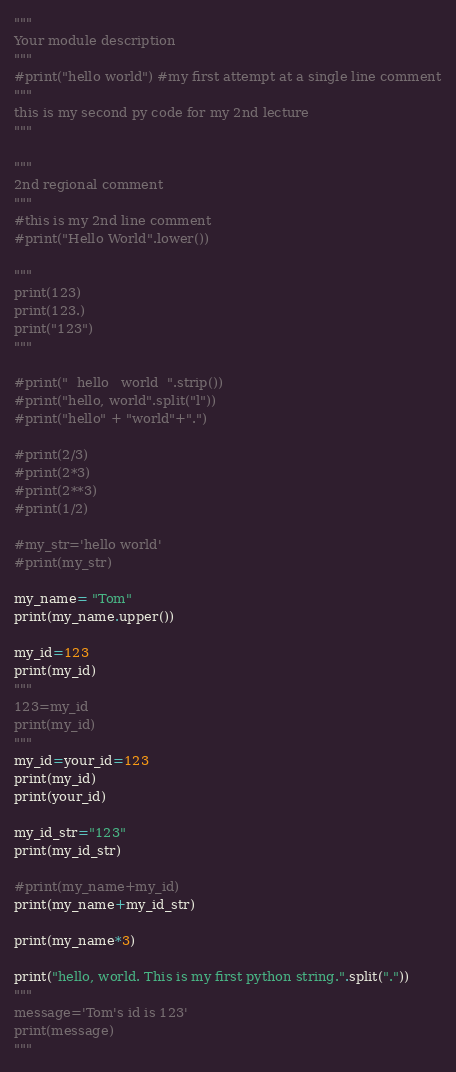Convert code to text. <code><loc_0><loc_0><loc_500><loc_500><_Python_>"""
Your module description
"""
#print("hello world") #my first attempt at a single line comment
"""
this is my second py code for my 2nd lecture
"""

"""
2nd regional comment
"""
#this is my 2nd line comment
#print("Hello World".lower())

"""
print(123)
print(123.)
print("123")
"""

#print("  hello   world  ".strip())
#print("hello, world".split("l"))
#print("hello" + "world"+".")

#print(2/3)
#print(2*3)
#print(2**3)
#print(1/2)

#my_str='hello world'
#print(my_str)

my_name= "Tom"
print(my_name.upper())

my_id=123
print(my_id)
"""
123=my_id
print(my_id)
"""
my_id=your_id=123
print(my_id)
print(your_id)

my_id_str="123"
print(my_id_str)

#print(my_name+my_id)
print(my_name+my_id_str)

print(my_name*3)

print("hello, world. This is my first python string.".split("."))
"""
message='Tom's id is 123'
print(message)
"""</code> 